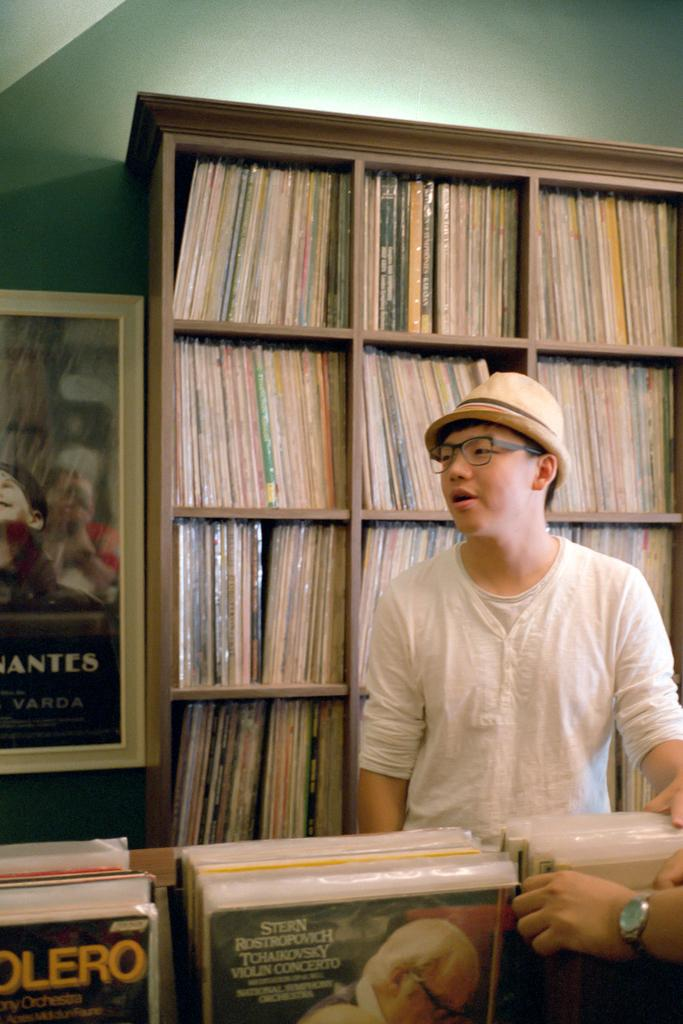<image>
Summarize the visual content of the image. A man is in a record shop and one of the records is for Tchaikovsky 